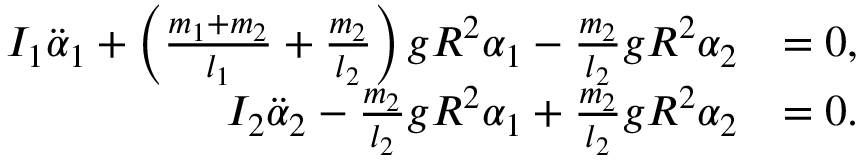<formula> <loc_0><loc_0><loc_500><loc_500>\begin{array} { r l } { I _ { 1 } \ddot { \alpha } _ { 1 } + \left ( \frac { m _ { 1 } + m _ { 2 } } { l _ { 1 } } + \frac { m _ { 2 } } { l _ { 2 } } \right ) g R ^ { 2 } \alpha _ { 1 } - \frac { m _ { 2 } } { l _ { 2 } } g R ^ { 2 } \alpha _ { 2 } } & { = 0 , } \\ { I _ { 2 } \ddot { \alpha } _ { 2 } - \frac { m _ { 2 } } { l _ { 2 } } g R ^ { 2 } \alpha _ { 1 } + \frac { m _ { 2 } } { l _ { 2 } } g R ^ { 2 } \alpha _ { 2 } } & { = 0 . } \end{array}</formula> 